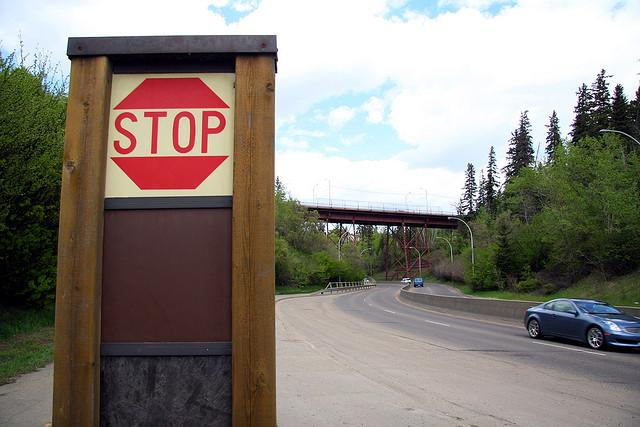What does the sign say?
Be succinct. Stop. Where on the sign holder is the sign?
Be succinct. Top. How many lamp posts are there?
Keep it brief. 4. 